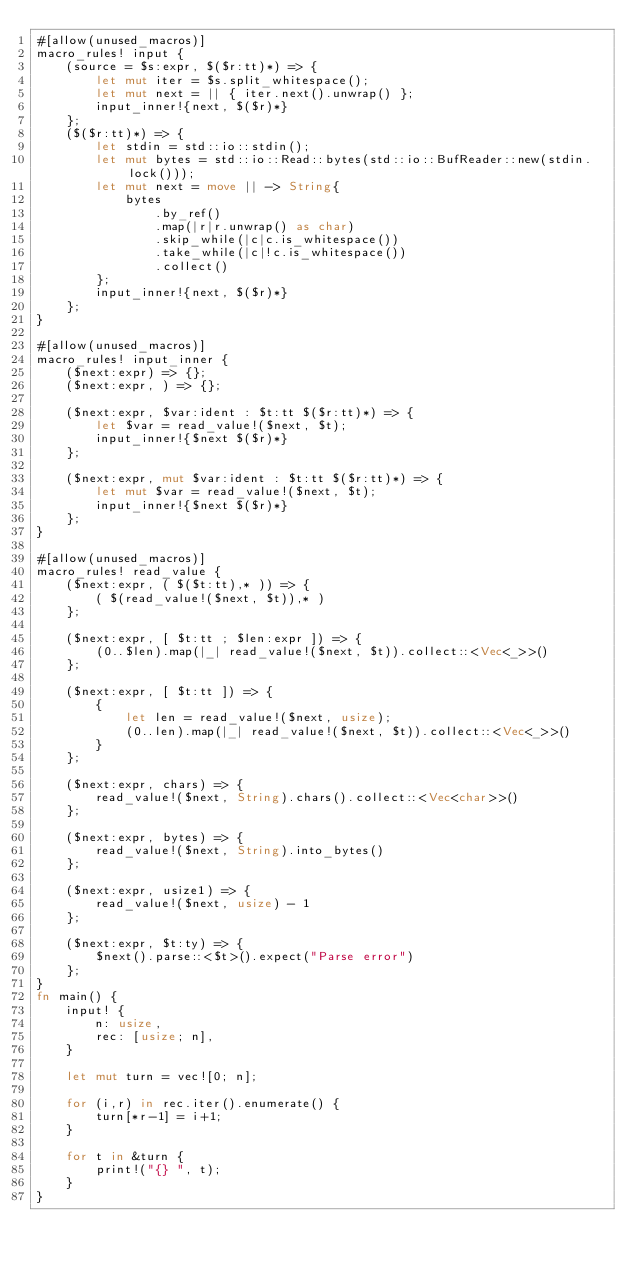<code> <loc_0><loc_0><loc_500><loc_500><_Rust_>#[allow(unused_macros)]
macro_rules! input {
    (source = $s:expr, $($r:tt)*) => {
        let mut iter = $s.split_whitespace();
        let mut next = || { iter.next().unwrap() };
        input_inner!{next, $($r)*}
    };
    ($($r:tt)*) => {
        let stdin = std::io::stdin();
        let mut bytes = std::io::Read::bytes(std::io::BufReader::new(stdin.lock()));
        let mut next = move || -> String{
            bytes
                .by_ref()
                .map(|r|r.unwrap() as char)
                .skip_while(|c|c.is_whitespace())
                .take_while(|c|!c.is_whitespace())
                .collect()
        };
        input_inner!{next, $($r)*}
    };
}
 
#[allow(unused_macros)]
macro_rules! input_inner {
    ($next:expr) => {};
    ($next:expr, ) => {};
 
    ($next:expr, $var:ident : $t:tt $($r:tt)*) => {
        let $var = read_value!($next, $t);
        input_inner!{$next $($r)*}
    };
 
    ($next:expr, mut $var:ident : $t:tt $($r:tt)*) => {
        let mut $var = read_value!($next, $t);
        input_inner!{$next $($r)*}
    };
}
 
#[allow(unused_macros)]
macro_rules! read_value {
    ($next:expr, ( $($t:tt),* )) => {
        ( $(read_value!($next, $t)),* )
    };
 
    ($next:expr, [ $t:tt ; $len:expr ]) => {
        (0..$len).map(|_| read_value!($next, $t)).collect::<Vec<_>>()
    };
 
    ($next:expr, [ $t:tt ]) => {
        {
            let len = read_value!($next, usize);
            (0..len).map(|_| read_value!($next, $t)).collect::<Vec<_>>()
        }
    };
 
    ($next:expr, chars) => {
        read_value!($next, String).chars().collect::<Vec<char>>()
    };
 
    ($next:expr, bytes) => {
        read_value!($next, String).into_bytes()
    };
 
    ($next:expr, usize1) => {
        read_value!($next, usize) - 1
    };
 
    ($next:expr, $t:ty) => {
        $next().parse::<$t>().expect("Parse error")
    };
}
fn main() {
    input! {
        n: usize,
        rec: [usize; n],
    }

    let mut turn = vec![0; n];

    for (i,r) in rec.iter().enumerate() {
        turn[*r-1] = i+1;
    }

    for t in &turn {
        print!("{} ", t);
    }
}
</code> 